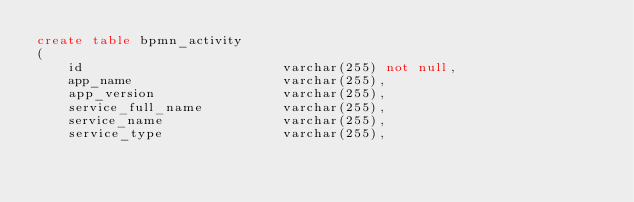<code> <loc_0><loc_0><loc_500><loc_500><_SQL_>create table bpmn_activity
(
    id                         varchar(255) not null,
    app_name                   varchar(255),
    app_version                varchar(255),
    service_full_name          varchar(255),
    service_name               varchar(255),
    service_type               varchar(255),</code> 